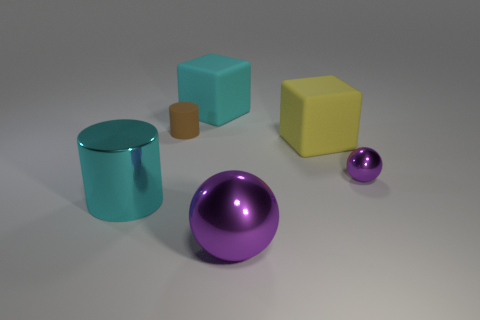How many other things are there of the same size as the brown matte cylinder?
Provide a short and direct response. 1. There is a purple ball in front of the cyan thing that is to the left of the big cyan rubber thing; what size is it?
Keep it short and to the point. Large. What number of small objects are yellow rubber objects or cyan rubber blocks?
Provide a short and direct response. 0. How big is the yellow rubber object behind the shiny sphere in front of the sphere on the right side of the yellow object?
Provide a short and direct response. Large. Is there any other thing that has the same color as the big sphere?
Your answer should be very brief. Yes. There is a large block on the right side of the cyan thing that is to the right of the big cyan object left of the large cyan matte cube; what is its material?
Your response must be concise. Rubber. Do the tiny brown thing and the yellow rubber thing have the same shape?
Your answer should be compact. No. Is there anything else that is the same material as the big yellow block?
Make the answer very short. Yes. What number of big things are both behind the small purple object and on the left side of the yellow cube?
Keep it short and to the point. 1. There is a tiny thing on the right side of the yellow matte object behind the big ball; what color is it?
Ensure brevity in your answer.  Purple. 